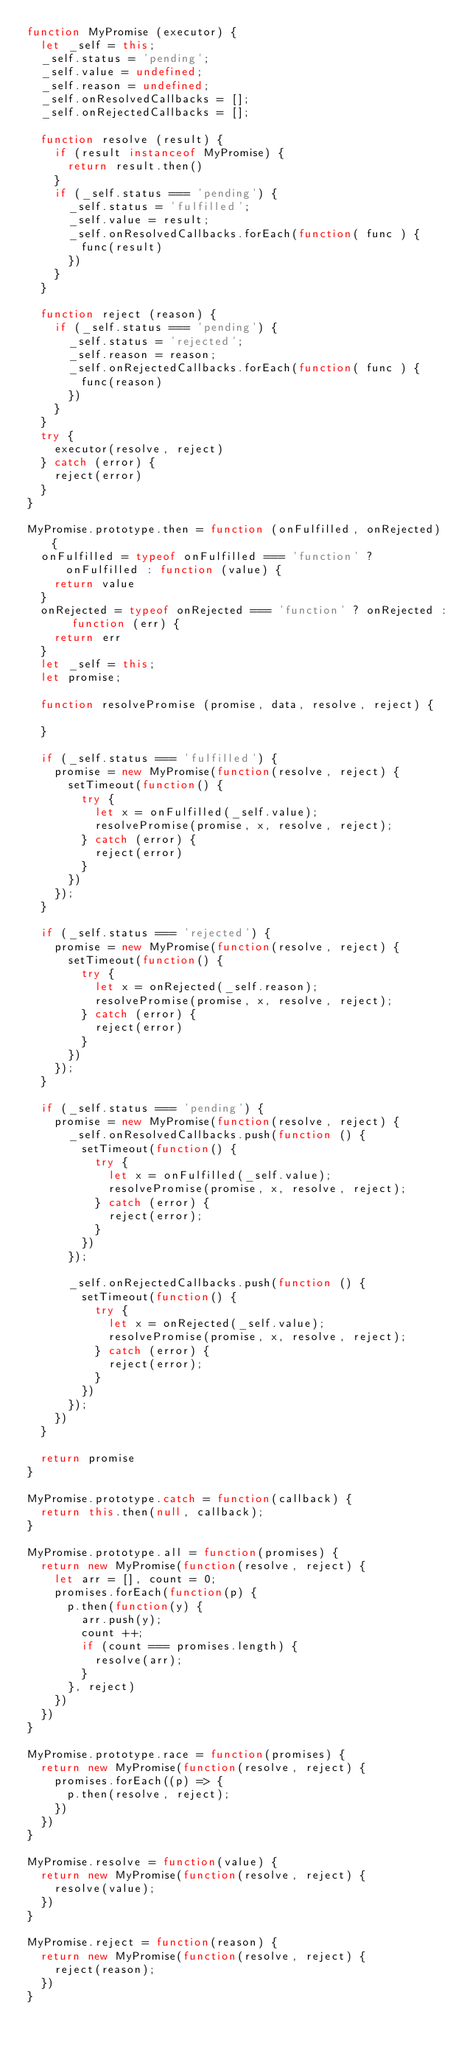Convert code to text. <code><loc_0><loc_0><loc_500><loc_500><_JavaScript_>function MyPromise (executor) {
  let _self = this;
  _self.status = 'pending';
  _self.value = undefined;
  _self.reason = undefined;
  _self.onResolvedCallbacks = [];
  _self.onRejectedCallbacks = [];

  function resolve (result) {
    if (result instanceof MyPromise) {
      return result.then()
    }
    if (_self.status === 'pending') {
      _self.status = 'fulfilled';
      _self.value = result;
      _self.onResolvedCallbacks.forEach(function( func ) {
        func(result)
      })
    }
  }

  function reject (reason) {
    if (_self.status === 'pending') {
      _self.status = 'rejected';
      _self.reason = reason;
      _self.onRejectedCallbacks.forEach(function( func ) {
        func(reason)
      })
    }
  }
  try {
    executor(resolve, reject)
  } catch (error) {
    reject(error) 
  }
}

MyPromise.prototype.then = function (onFulfilled, onRejected) {
  onFulfilled = typeof onFulfilled === 'function' ? onFulfilled : function (value) {
    return value
  }
  onRejected = typeof onRejected === 'function' ? onRejected : function (err) {
    return err
  }
  let _self = this;
  let promise;

  function resolvePromise (promise, data, resolve, reject) {

  }

  if (_self.status === 'fulfilled') {
    promise = new MyPromise(function(resolve, reject) {
      setTimeout(function() {
        try {
          let x = onFulfilled(_self.value);
          resolvePromise(promise, x, resolve, reject);
        } catch (error) {
          reject(error)
        }
      })
    });
  }

  if (_self.status === 'rejected') {
    promise = new MyPromise(function(resolve, reject) {
      setTimeout(function() {
        try {
          let x = onRejected(_self.reason);
          resolvePromise(promise, x, resolve, reject);
        } catch (error) {
          reject(error)
        }
      })
    });
  }

  if (_self.status === 'pending') {
    promise = new MyPromise(function(resolve, reject) {
      _self.onResolvedCallbacks.push(function () {
        setTimeout(function() {
          try {
            let x = onFulfilled(_self.value);
            resolvePromise(promise, x, resolve, reject);
          } catch (error) {
            reject(error);
          }
        })
      });

      _self.onRejectedCallbacks.push(function () {
        setTimeout(function() {
          try {
            let x = onRejected(_self.value);
            resolvePromise(promise, x, resolve, reject);
          } catch (error) {
            reject(error);
          }
        })
      });
    })
  }

  return promise
}

MyPromise.prototype.catch = function(callback) {
  return this.then(null, callback);
}

MyPromise.prototype.all = function(promises) {
  return new MyPromise(function(resolve, reject) {
    let arr = [], count = 0;
    promises.forEach(function(p) {
      p.then(function(y) {
        arr.push(y);
        count ++;
        if (count === promises.length) {
          resolve(arr);
        }
      }, reject)
    })
  })
}

MyPromise.prototype.race = function(promises) {
  return new MyPromise(function(resolve, reject) {
    promises.forEach((p) => {
      p.then(resolve, reject);
    })
  })
}

MyPromise.resolve = function(value) {
  return new MyPromise(function(resolve, reject) {
    resolve(value);
  })
}

MyPromise.reject = function(reason) {
  return new MyPromise(function(resolve, reject) {
    reject(reason);
  })
}

</code> 